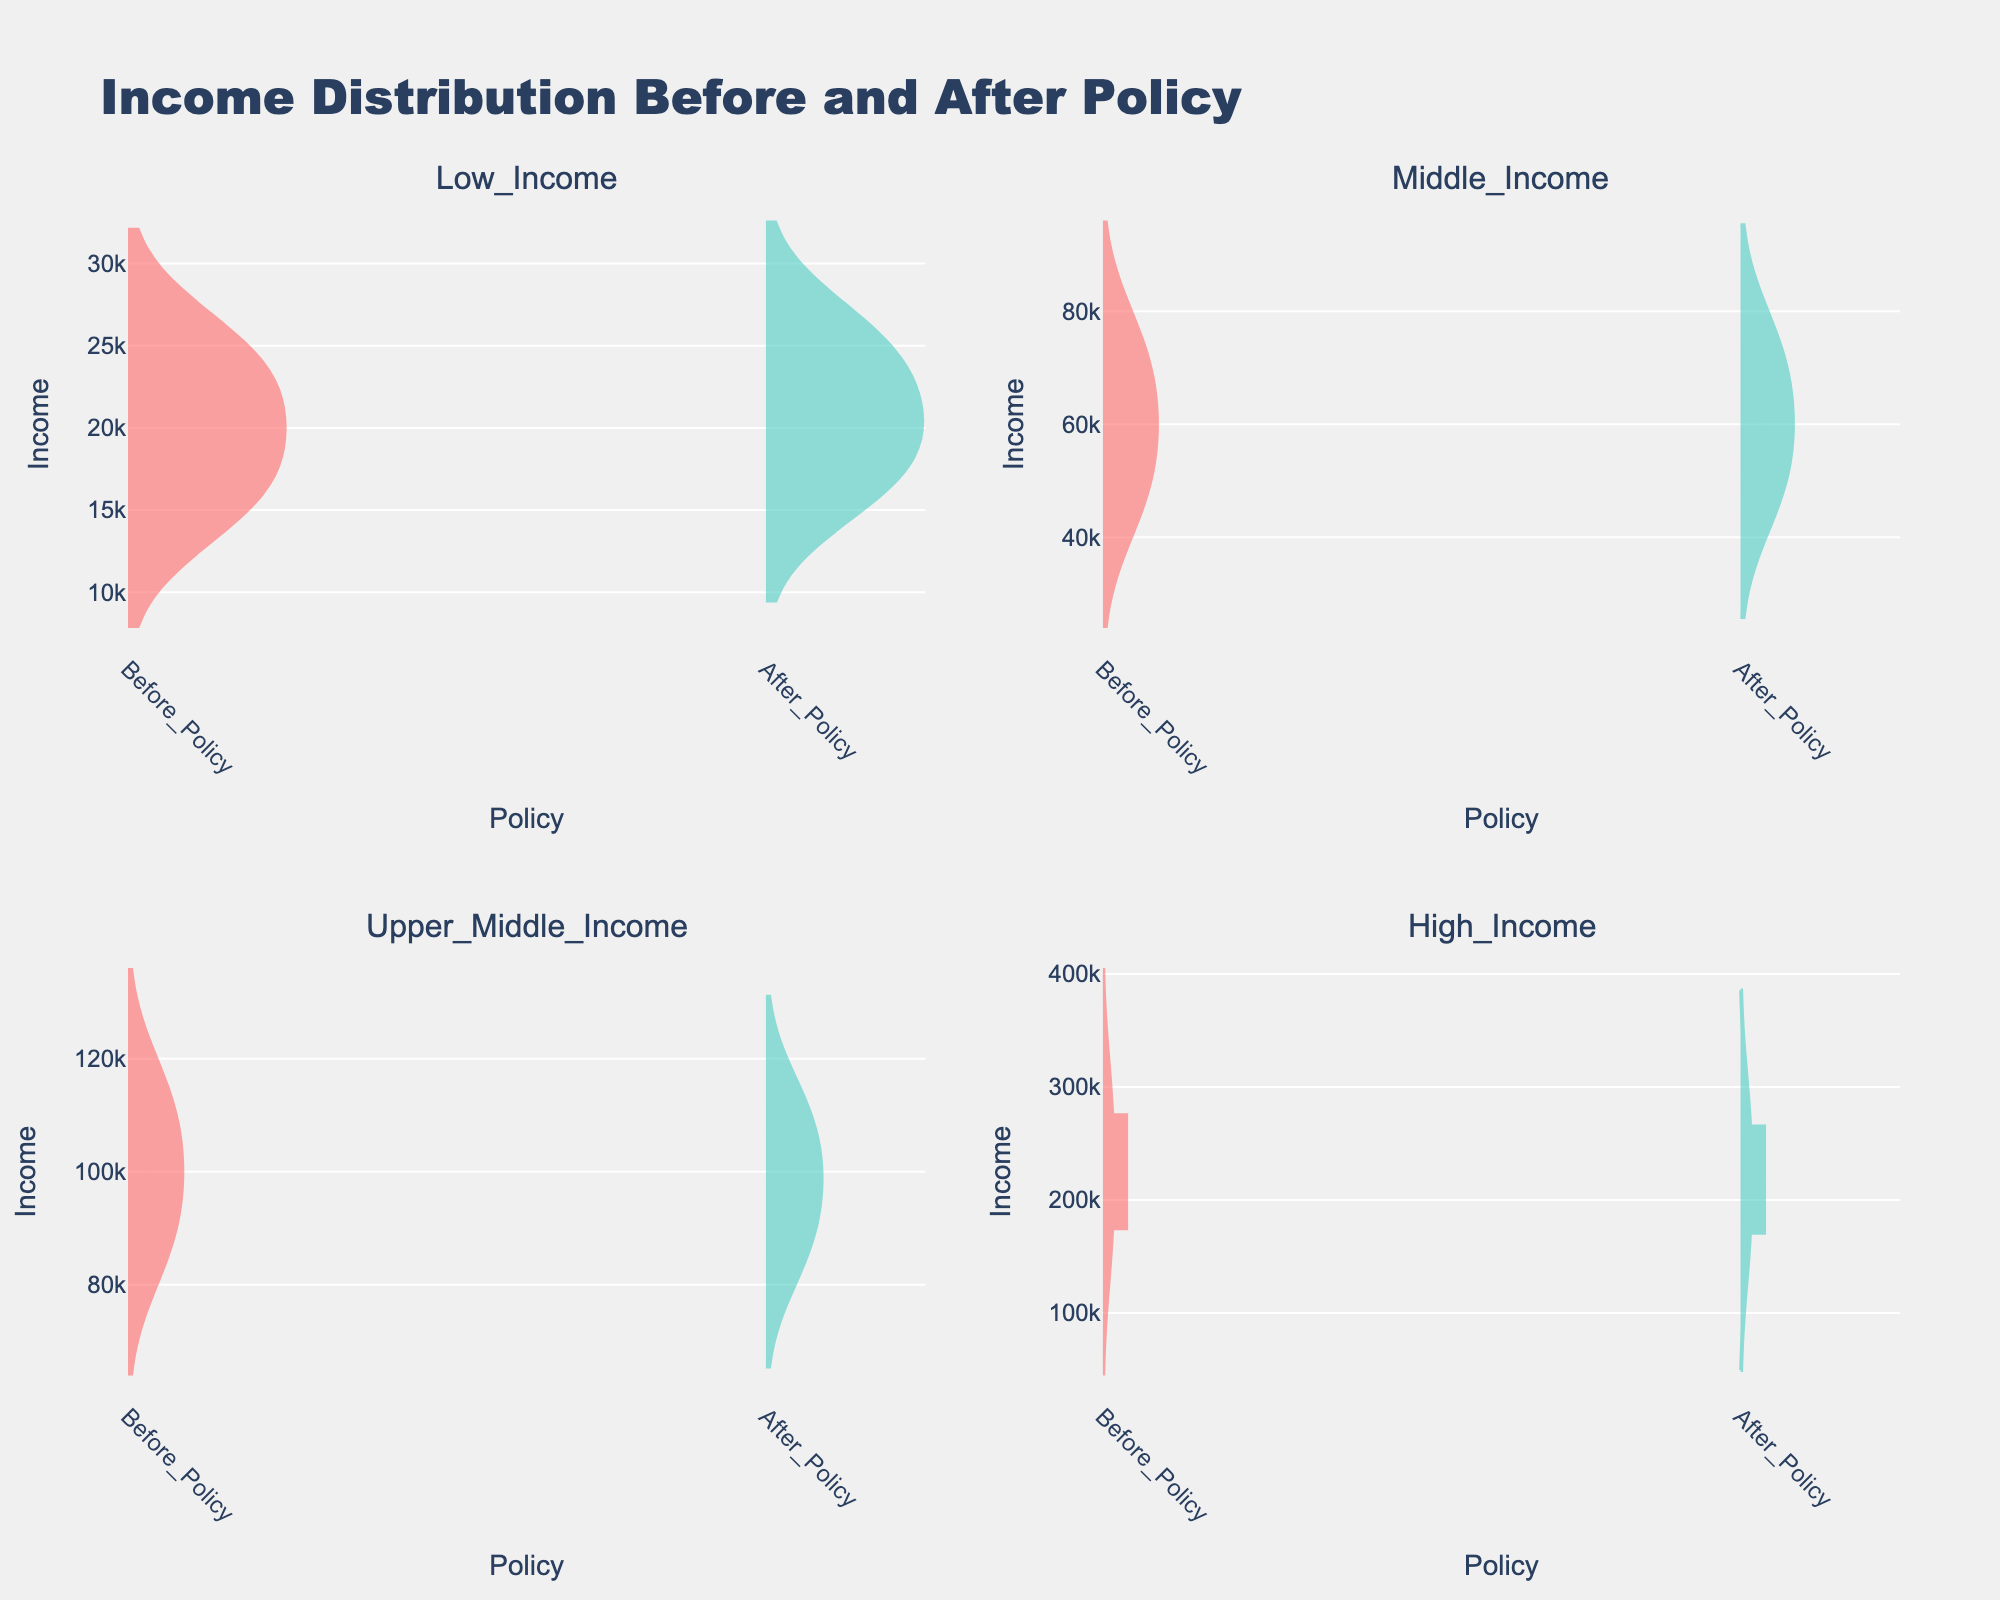What is the title of the figure? The title is the main text above the whole figure that describes what the visual is about. It's placed in the top center of the plot.
Answer: Income Distribution Before and After Policy How many income groups are displayed in the figure? The figure contains subplots for different income groups, each with a title specifying the group. Counting these titles reveals the number of groups.
Answer: 4 Which income group has the highest median income after the policy? To determine this, look at the violin plots for each group after the policy. The median is indicated by the thick dashed line. Compare the positions of these lines to find the highest one.
Answer: High_Income Did the Low_Income group's median income increase or decrease after the policy? Check the median lines within the Low_Income subplot before and after the policy. Compare these lines to see if there's an increase or decrease.
Answer: Increase Compare the range of incomes for Middle_Income group before and after the policy. Look at the spread of the data points (violin plots) for the Middle_Income group for both times. Observing the range from the lowest to the highest data point will show any changes in range.
Answer: The range changed slightly; the upper bound remains similar, with a minor increase in the lower bound Which group experienced the most significant change in the median income due to the policy? Examine the median lines across all subplots before and after the policy. Calculate the difference in these lines' positions for each group. Compare these differences to identify the highest one.
Answer: High_Income Is the box at the center of the violin plots visible for all policies and groups? Check each violin plot in the subplots for a central box. This box represents the interquartile range, and its visibility needs to be confirmed for all groups and policies.
Answer: Yes Do the income distributions become more or less spread out after the policy for Upper_Middle_Income? Look at the thickness of the violin plots before and after the policy for the Upper_Middle_Income subplot. A wider plot indicates more variability, and a narrower plot indicates less.
Answer: Less spread out How does the income distribution for High_Income group compare before and after the policy? Assess the violin plots for the High_Income group before and after the policy. Note changes in median, range, and overall shape to understand the distribution changes.
Answer: The median decreases, and the overall distribution shifts downward after the policy What is the color used to represent incomes after the policy? The color used for incomes after the policy is consistent across all subplots. Observing one subplot will provide the color.
Answer: Green 